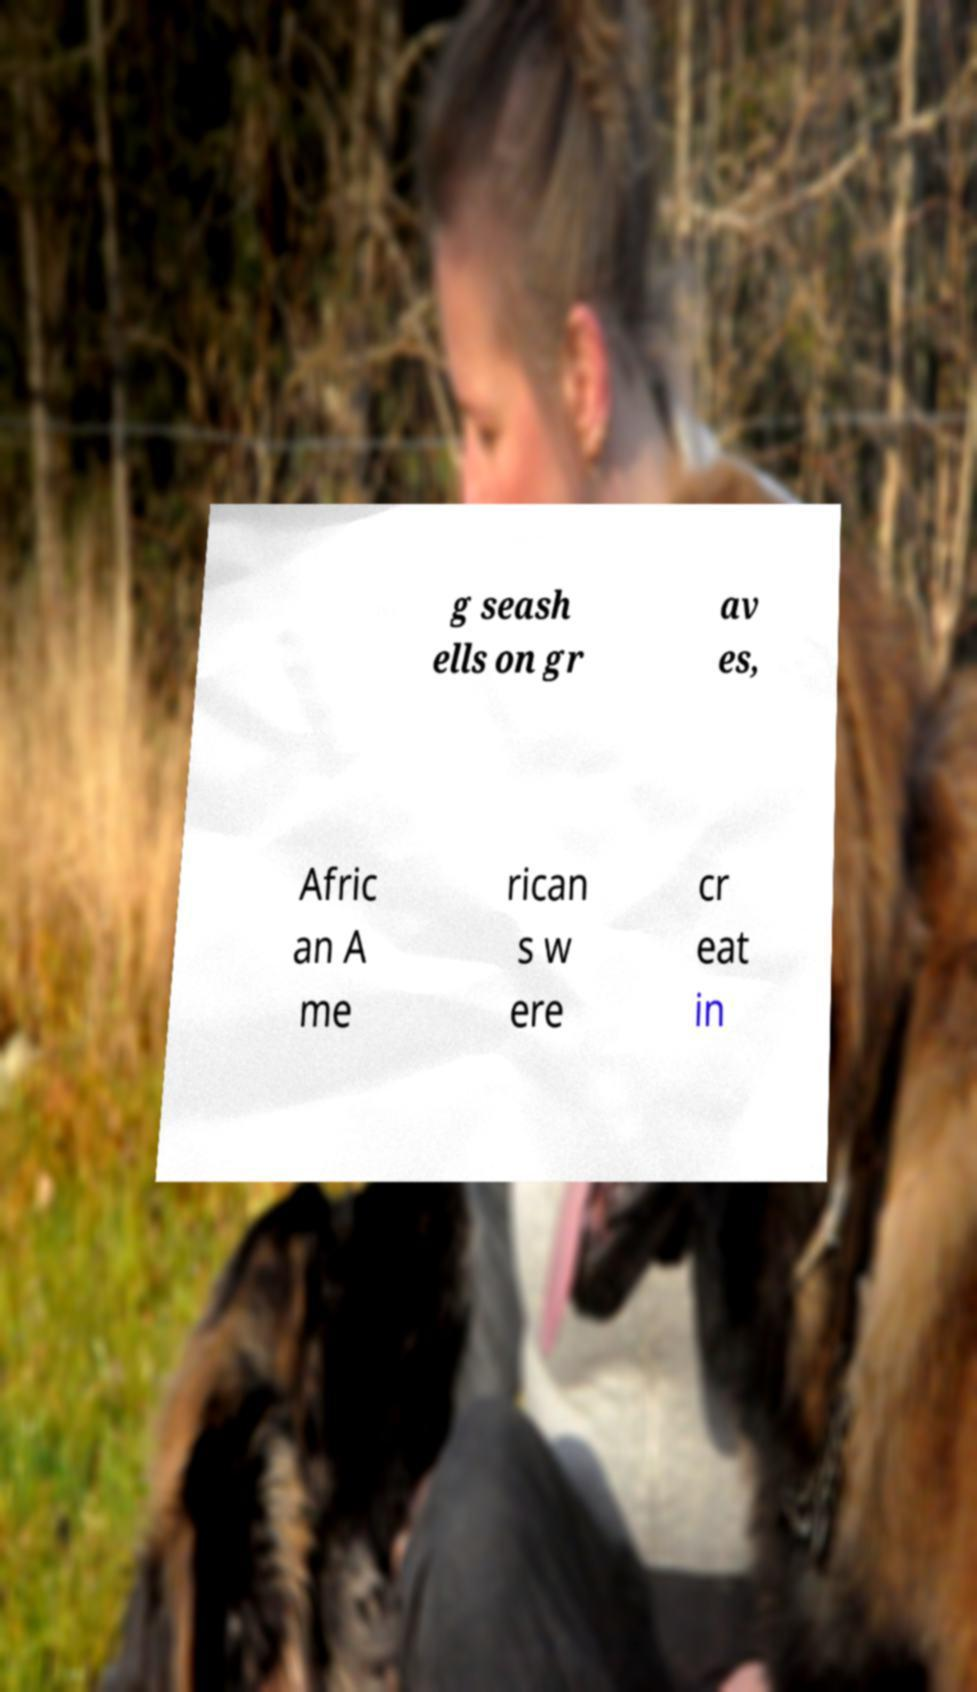Please read and relay the text visible in this image. What does it say? g seash ells on gr av es, Afric an A me rican s w ere cr eat in 